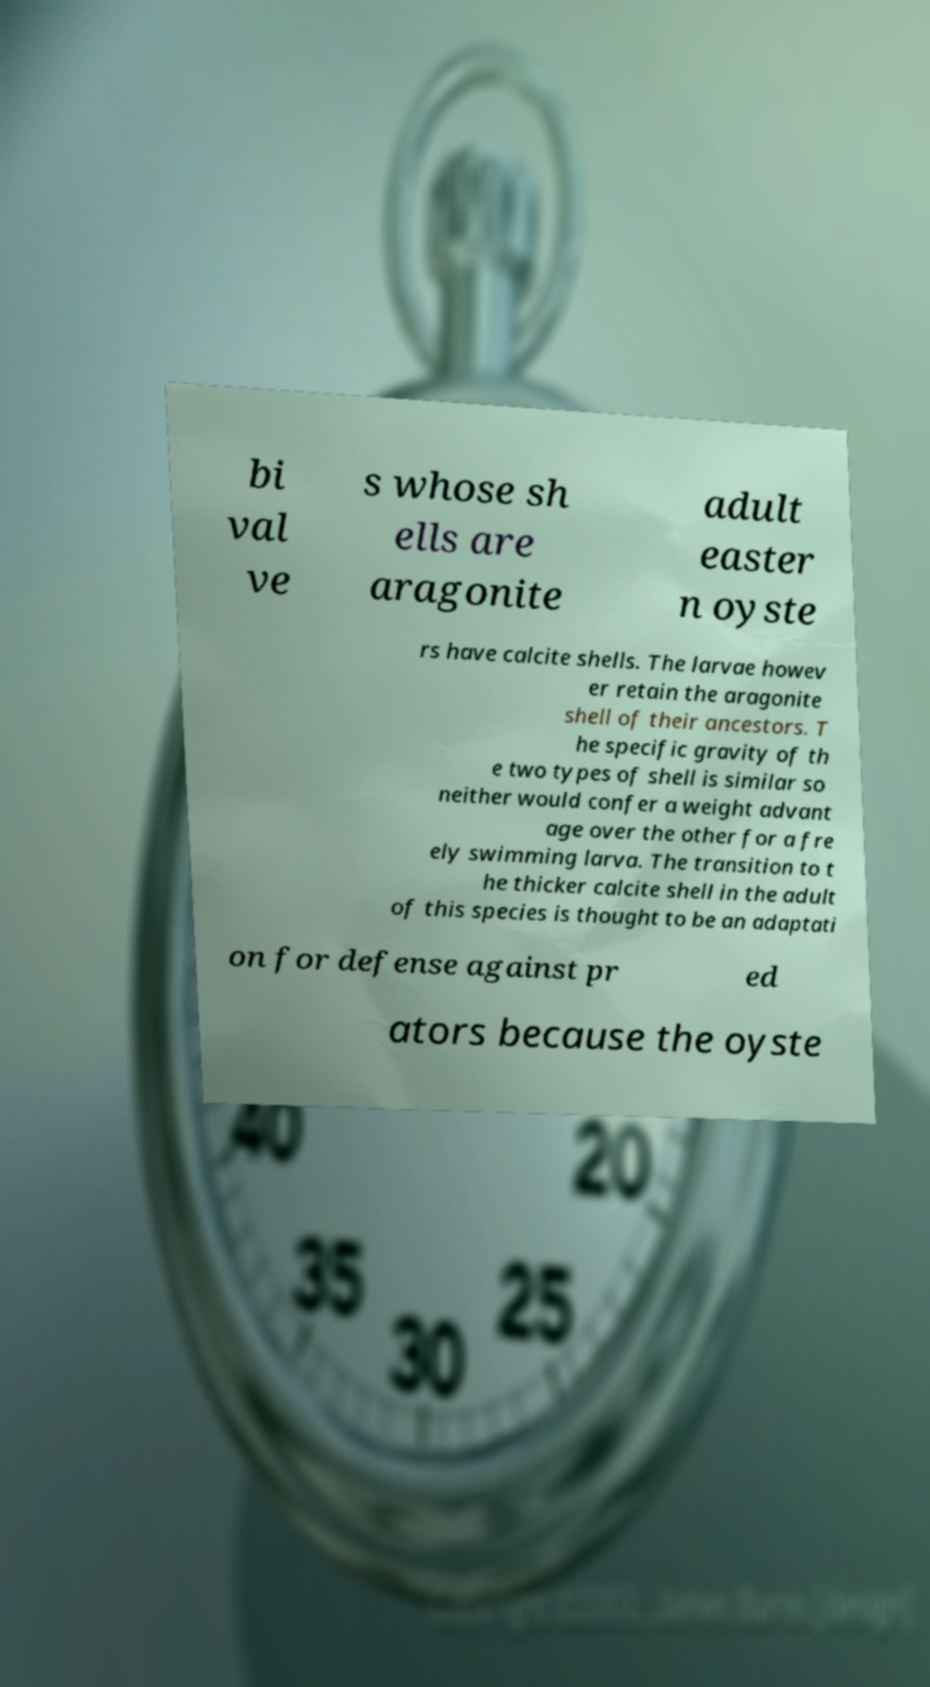Could you extract and type out the text from this image? bi val ve s whose sh ells are aragonite adult easter n oyste rs have calcite shells. The larvae howev er retain the aragonite shell of their ancestors. T he specific gravity of th e two types of shell is similar so neither would confer a weight advant age over the other for a fre ely swimming larva. The transition to t he thicker calcite shell in the adult of this species is thought to be an adaptati on for defense against pr ed ators because the oyste 